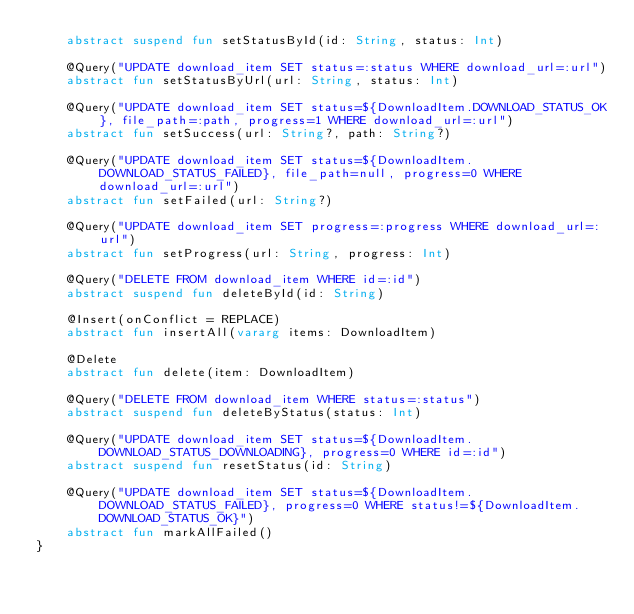<code> <loc_0><loc_0><loc_500><loc_500><_Kotlin_>    abstract suspend fun setStatusById(id: String, status: Int)

    @Query("UPDATE download_item SET status=:status WHERE download_url=:url")
    abstract fun setStatusByUrl(url: String, status: Int)

    @Query("UPDATE download_item SET status=${DownloadItem.DOWNLOAD_STATUS_OK}, file_path=:path, progress=1 WHERE download_url=:url")
    abstract fun setSuccess(url: String?, path: String?)

    @Query("UPDATE download_item SET status=${DownloadItem.DOWNLOAD_STATUS_FAILED}, file_path=null, progress=0 WHERE download_url=:url")
    abstract fun setFailed(url: String?)

    @Query("UPDATE download_item SET progress=:progress WHERE download_url=:url")
    abstract fun setProgress(url: String, progress: Int)

    @Query("DELETE FROM download_item WHERE id=:id")
    abstract suspend fun deleteById(id: String)

    @Insert(onConflict = REPLACE)
    abstract fun insertAll(vararg items: DownloadItem)

    @Delete
    abstract fun delete(item: DownloadItem)

    @Query("DELETE FROM download_item WHERE status=:status")
    abstract suspend fun deleteByStatus(status: Int)

    @Query("UPDATE download_item SET status=${DownloadItem.DOWNLOAD_STATUS_DOWNLOADING}, progress=0 WHERE id=:id")
    abstract suspend fun resetStatus(id: String)

    @Query("UPDATE download_item SET status=${DownloadItem.DOWNLOAD_STATUS_FAILED}, progress=0 WHERE status!=${DownloadItem.DOWNLOAD_STATUS_OK}")
    abstract fun markAllFailed()
}</code> 